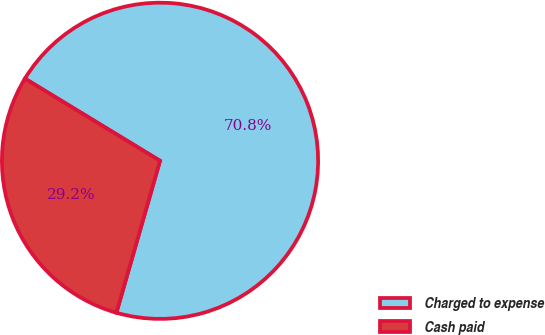<chart> <loc_0><loc_0><loc_500><loc_500><pie_chart><fcel>Charged to expense<fcel>Cash paid<nl><fcel>70.75%<fcel>29.25%<nl></chart> 